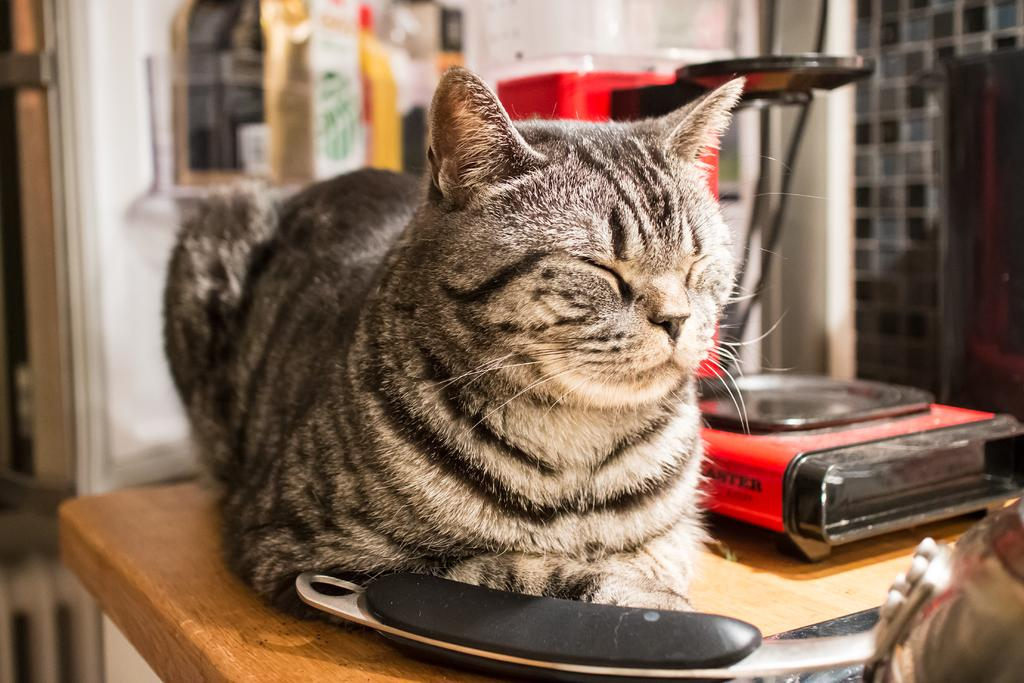What type of animal is in the image? There is a cat in the image. What object is present in the image besides the cat? There is a box in the image. What is the object on the wooden surface in the image? The object on the wooden surface is not specified in the facts. What can be seen behind the cat in the image? There is a wall visible behind the cat. What type of flooring is visible in the background? There are tiles visible in the background. How is the background of the image depicted? The background is blurred. What question is the cat asking in the image? There is no indication in the image that the cat is asking a question. 